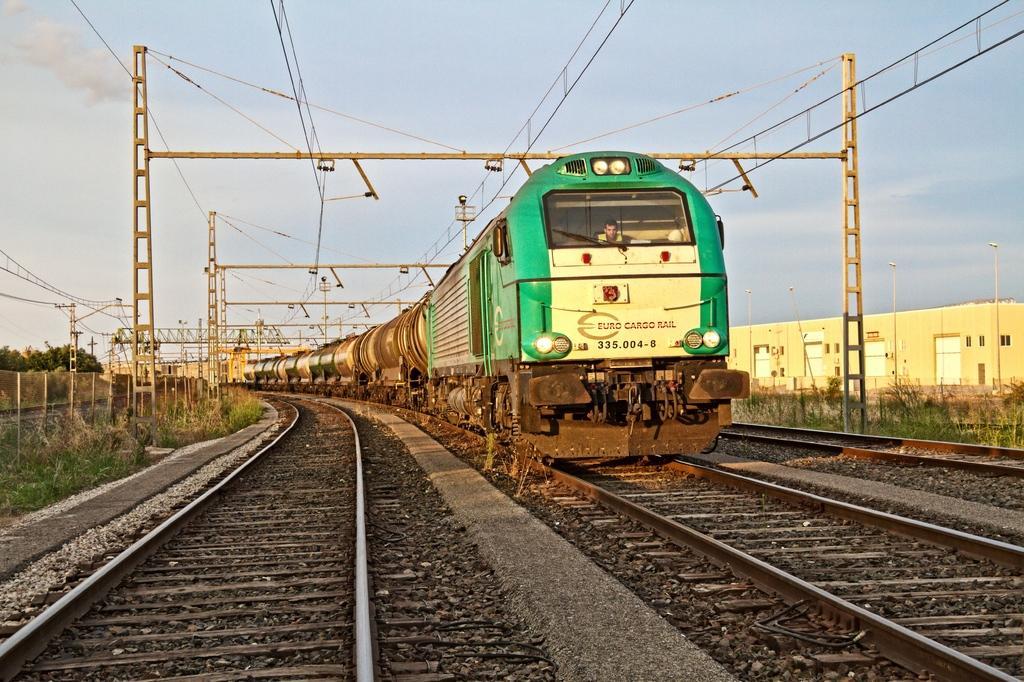Describe this image in one or two sentences. In this image, we can see the train and some tracks. We can also see some grass, trees and some stones. There are some poles and stands. We can also see the fence. We can also see a building on the right. We can see the sky. 